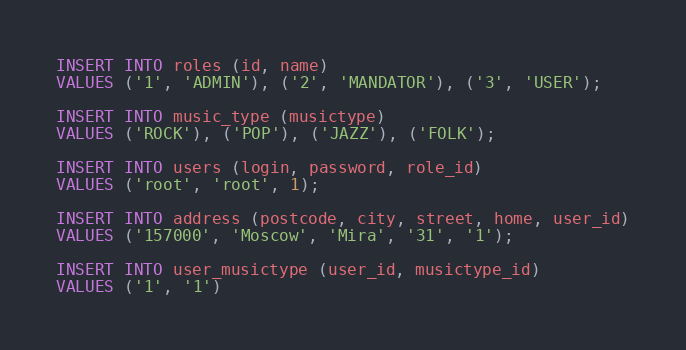<code> <loc_0><loc_0><loc_500><loc_500><_SQL_>INSERT INTO roles (id, name)
VALUES ('1', 'ADMIN'), ('2', 'MANDATOR'), ('3', 'USER');

INSERT INTO music_type (musictype)
VALUES ('ROCK'), ('POP'), ('JAZZ'), ('FOLK');

INSERT INTO users (login, password, role_id)
VALUES ('root', 'root', 1);

INSERT INTO address (postcode, city, street, home, user_id)
VALUES ('157000', 'Moscow', 'Mira', '31', '1');

INSERT INTO user_musictype (user_id, musictype_id)
VALUES ('1', '1')</code> 